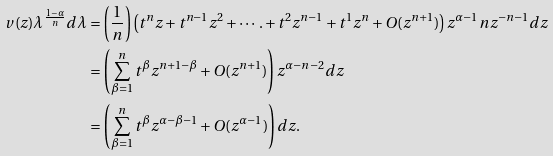<formula> <loc_0><loc_0><loc_500><loc_500>v ( z ) \lambda ^ { \frac { 1 - \alpha } { n } } d \lambda & = \left ( \frac { 1 } { n } \right ) \left ( t ^ { n } z + t ^ { n - 1 } z ^ { 2 } + \cdots . + t ^ { 2 } z ^ { n - 1 } + t ^ { 1 } z ^ { n } + O ( z ^ { n + 1 } ) \right ) z ^ { \alpha - 1 } n z ^ { - n - 1 } d z \\ & = \left ( \sum _ { \beta = 1 } ^ { n } t ^ { \beta } z ^ { n + 1 - \beta } + O ( z ^ { n + 1 } ) \right ) z ^ { \alpha - n - 2 } d z \\ & = \left ( \sum _ { \beta = 1 } ^ { n } t ^ { \beta } z ^ { \alpha - \beta - 1 } + O ( z ^ { \alpha - 1 } ) \right ) d z .</formula> 